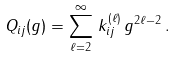Convert formula to latex. <formula><loc_0><loc_0><loc_500><loc_500>Q _ { i j } ( g ) = \sum _ { \ell = 2 } ^ { \infty } \, k ^ { ( \ell ) } _ { i j } \, g ^ { 2 \ell - 2 } \, .</formula> 